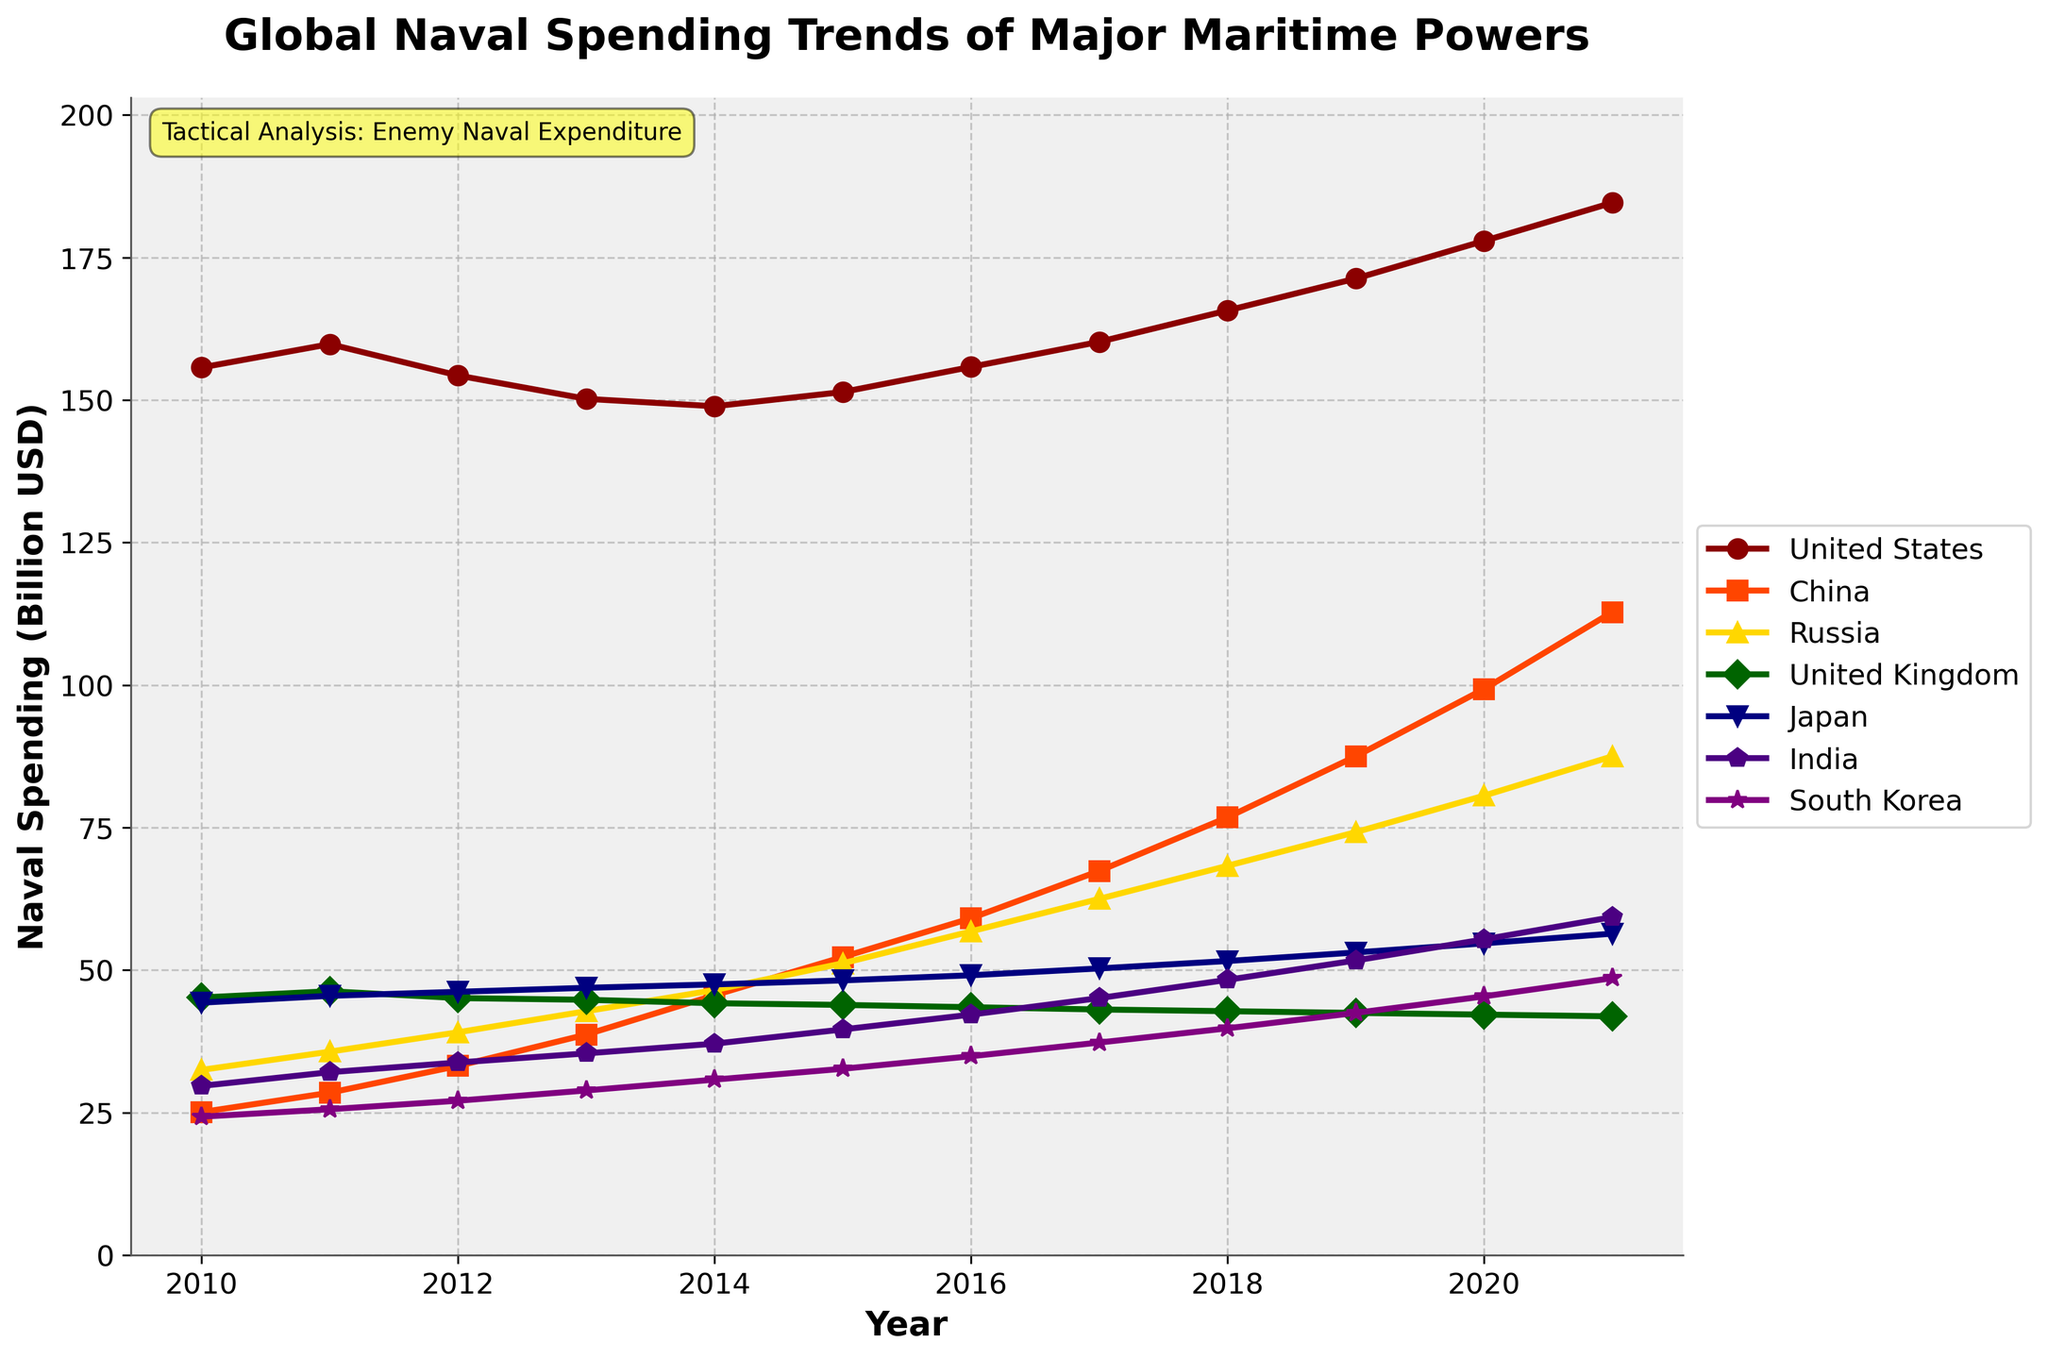What is the trend in naval spending for China from 2010 to 2021? Observing the plot, China's naval spending increases steadily each year from 25.1 billion USD in 2010 to 112.8 billion USD in 2021. The graph for China shows a clear upward trajectory.
Answer: Increasing Which country had the highest naval spending in 2021? At 184.6 billion USD, the United States had the highest naval spending in 2021. This is visually confirmed as the graph for the United States is the highest among all countries in 2021.
Answer: United States How did Russia's naval spending change compared to Japan from 2010 to 2021? Russia's naval spending increased from 32.5 billion USD in 2010 to 87.5 billion USD in 2021. Japan's naval spending also increased from 44.3 billion USD in 2010 to 56.4 billion USD in 2021. Russia's spending increased significantly more than Japan's.
Answer: Russia increased more In which year did India surpass Japan in naval spending? By checking the values plotted, India surpasses Japan in 2020 when India's spending hits 55.4 billion USD, compared to Japan's 54.7 billion USD. This change remains consistent in 2021 as well.
Answer: 2020 Which country experienced the largest relative increase in naval spending from 2010 to 2021? Calculating the relative increase: China (112.8/25.1 = 4.49) and Russia (87.5/32.5 = 2.69). The relative increase for China is the highest, as its naval spending is around 4.49 times higher in 2021 than in 2010.
Answer: China What is the combined naval spending of the United Kingdom and South Korea in 2015? Adding the values for 2015, the United Kingdom spent 43.9 billion USD, and South Korea spent 32.7 billion USD. Summing these amounts gives 43.9 + 32.7 = 76.6 billion USD.
Answer: 76.6 billion USD Which country had the steadiest increase in naval spending over the years, based on the slope of their graph line? Evaluating the smoothness and consistency of lines, China shows a steady and consistent upward trend in spending with no major fluctuations.
Answer: China Compare the naval spending between India and South Korea in 2013. Who spent more and by how much? In 2013, India spent 35.4 billion USD and South Korea spent 28.9 billion USD. India spent more, and the difference is 35.4 - 28.9 = 6.5 billion USD.
Answer: India by 6.5 billion USD What notable pattern or trend is observed in the naval spending of the United Kingdom from 2010 to 2021? The United Kingdom shows a slight decrease over the years from 45.2 billion USD in 2010 to 41.9 billion USD in 2021, with minor annual fluctuations.
Answer: Slight decrease Which country showed the highest increase in naval spending between 2018 and 2019 and how much was the increase? China experienced the highest increase between 2018 and 2019, from 76.8 billion USD to 87.5 billion USD. The increase is 87.5 - 76.8 = 10.7 billion USD.
Answer: China by 10.7 billion USD 